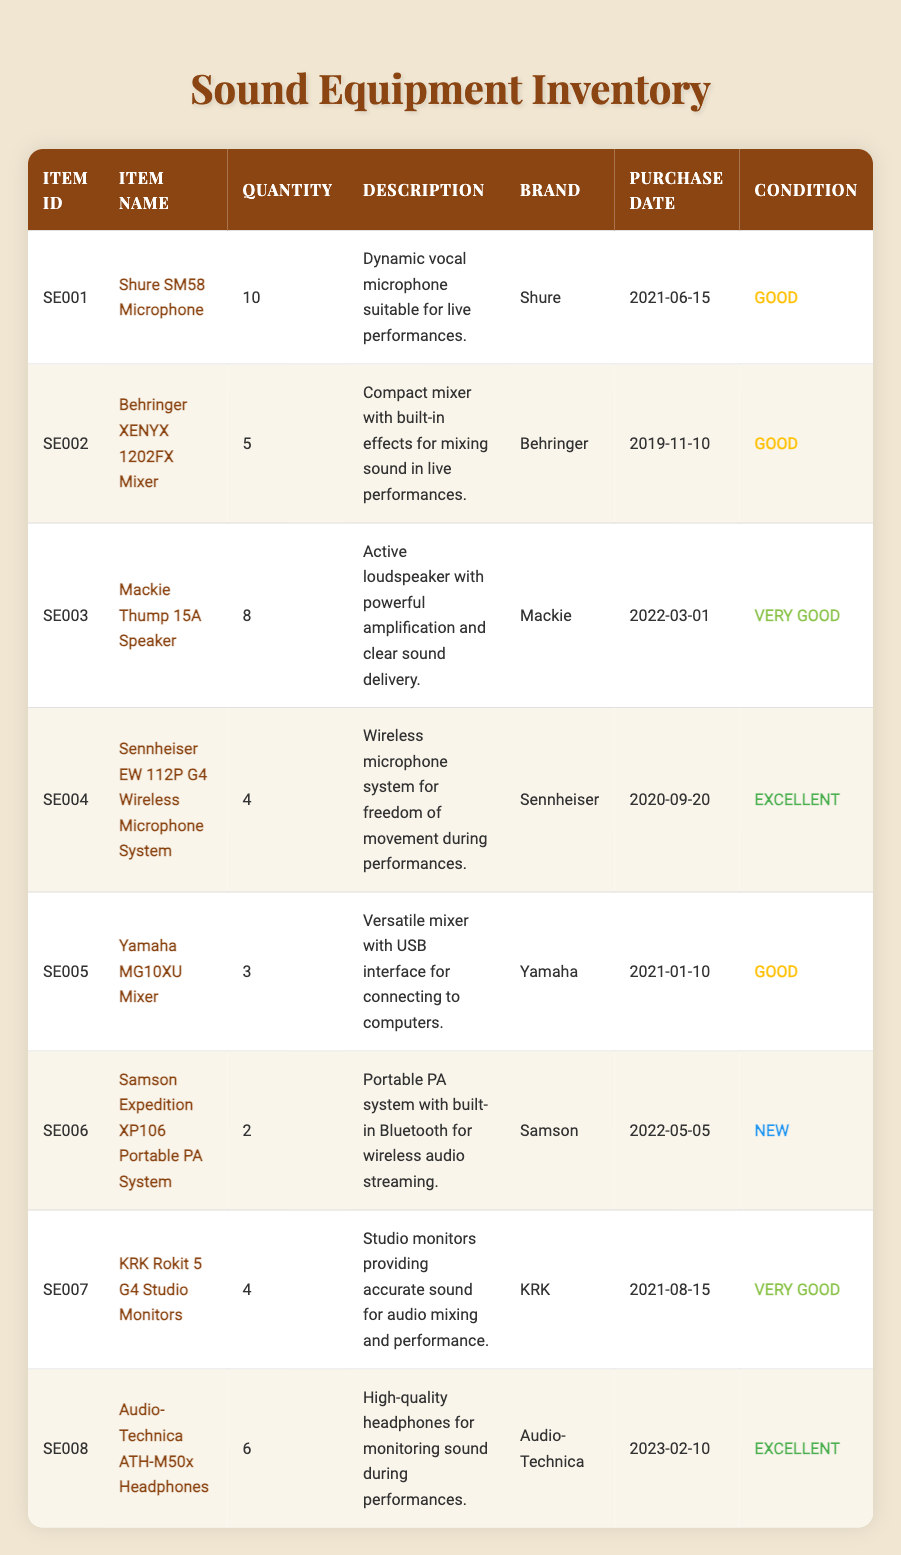What is the quantity of Shure SM58 Microphones available? The table lists the item "Shure SM58 Microphone" under the column for quantity. The corresponding quantity is 10.
Answer: 10 Which item has the best condition? By looking at the condition column, the items listed as "Excellent" are the "Sennheiser EW 112P G4 Wireless Microphone System" and "Audio-Technica ATH-M50x Headphones". Both items have the highest condition status available.
Answer: Sennheiser EW 112P G4 Wireless Microphone System and Audio-Technica ATH-M50x Headphones How many Behringer XENYX 1202FX Mixers are in inventory? The row for "Behringer XENYX 1202FX Mixer" shows its quantity in the quantity column, which equals 5.
Answer: 5 True or False: There are more KRK Rokit 5 G4 Studio Monitors than Mackie Thump 15A Speakers in inventory. The quantity for "KRK Rokit 5 G4 Studio Monitors" is 4 and for "Mackie Thump 15A Speaker" it is 8. Since 4 is less than 8, the statement is false.
Answer: False What is the total quantity of mixers in the inventory? The mixers in the inventory are the "Behringer XENYX 1202FX Mixer" with a quantity of 5 and the "Yamaha MG10XU Mixer" with a quantity of 3. Adding these gives 5 + 3 = 8.
Answer: 8 How many items have been purchased in 2021? Reviewing the purchase dates, the "Shure SM58 Microphone", "Yamaha MG10XU Mixer", and "KRK Rokit 5 G4 Studio Monitors" were purchased in 2021. This counts as three items purchased in that year.
Answer: 3 What is the difference in quantity between the most available sound equipment and the least available? The most available item is the "Shure SM58 Microphone" with a quantity of 10, and the least available are "Samson Expedition XP106 Portable PA System" with 2 units. The difference is 10 - 2 = 8.
Answer: 8 Which brand has more than 3 items available? The item "Shure SM58 Microphone" by Shure has 10 units, the "Behringer XENYX 1202FX Mixer" has 5, and the "Mackie Thump 15A Speaker" has 8. Therefore, Shure and Behringer both qualify as brands with more than 3 items in stock.
Answer: Shure and Behringer What is the average condition rating due to the types of conditions listed? Each condition can be assigned a numerical value: Excellent=4, Very Good=3, Good=2, New=5. There are 2 Excellent, 3 Very Good, 5 Good, and 2 New which when calculated gives (2*4 + 3*3 + 5*2 + 2*5)/12, leading to an average of (8 + 9 + 10 + 10)/12 = 37/12, which is approximately 3.08. This represents a mostly "Very Good" average rating.
Answer: Approximately 3.08 